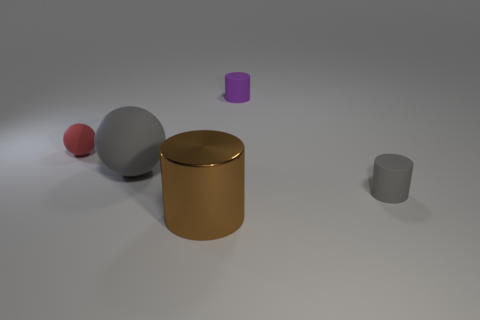Subtract all brown shiny cylinders. How many cylinders are left? 2 Subtract all gray spheres. How many spheres are left? 1 Subtract 2 cylinders. How many cylinders are left? 1 Add 2 red rubber cylinders. How many red rubber cylinders exist? 2 Add 1 red matte things. How many objects exist? 6 Subtract 1 red balls. How many objects are left? 4 Subtract all spheres. How many objects are left? 3 Subtract all brown cylinders. Subtract all green balls. How many cylinders are left? 2 Subtract all blue balls. How many yellow cylinders are left? 0 Subtract all matte cylinders. Subtract all red things. How many objects are left? 2 